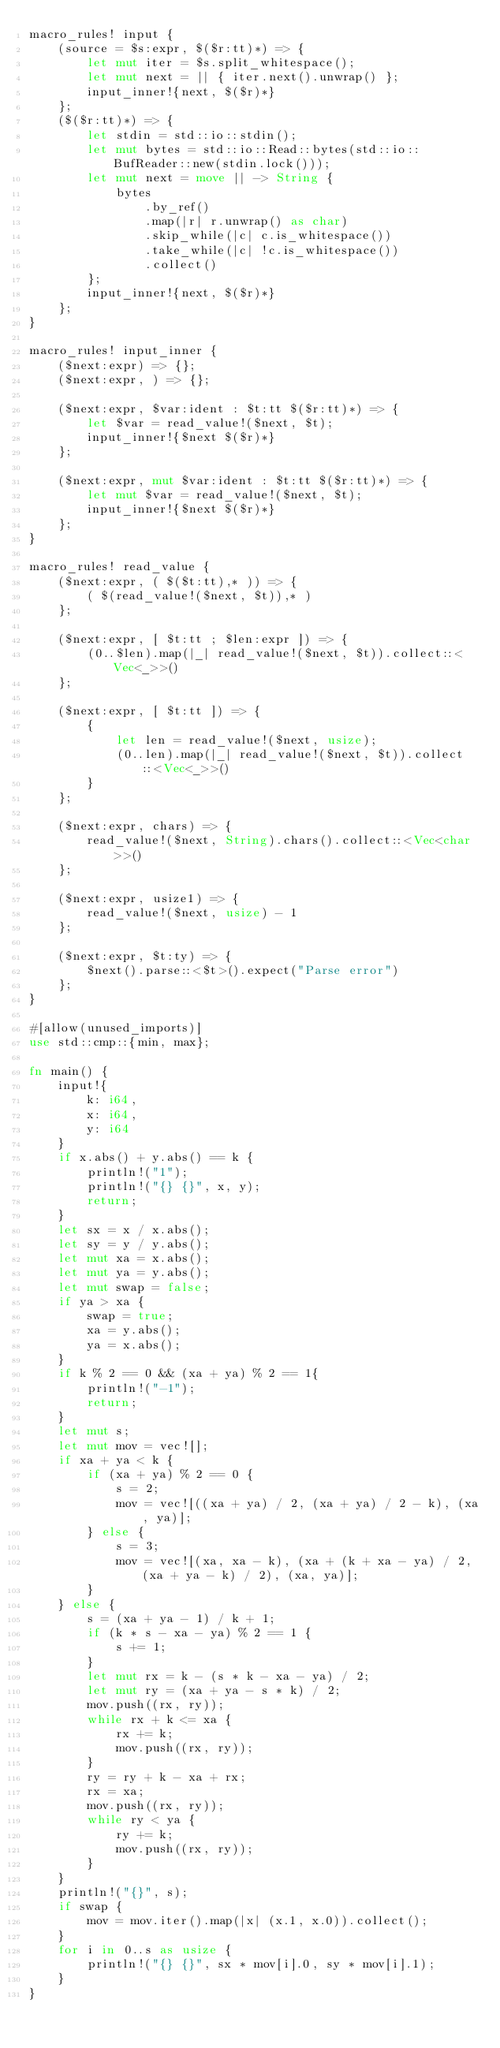Convert code to text. <code><loc_0><loc_0><loc_500><loc_500><_Rust_>macro_rules! input {
    (source = $s:expr, $($r:tt)*) => {
        let mut iter = $s.split_whitespace();
        let mut next = || { iter.next().unwrap() };
        input_inner!{next, $($r)*}
    };
    ($($r:tt)*) => {
        let stdin = std::io::stdin();
        let mut bytes = std::io::Read::bytes(std::io::BufReader::new(stdin.lock()));
        let mut next = move || -> String {
            bytes
                .by_ref()
                .map(|r| r.unwrap() as char)
                .skip_while(|c| c.is_whitespace())
                .take_while(|c| !c.is_whitespace())
                .collect()
        };
        input_inner!{next, $($r)*}
    };
}

macro_rules! input_inner {
    ($next:expr) => {};
    ($next:expr, ) => {};

    ($next:expr, $var:ident : $t:tt $($r:tt)*) => {
        let $var = read_value!($next, $t);
        input_inner!{$next $($r)*}
    };

    ($next:expr, mut $var:ident : $t:tt $($r:tt)*) => {
        let mut $var = read_value!($next, $t);
        input_inner!{$next $($r)*}
    };
}

macro_rules! read_value {
    ($next:expr, ( $($t:tt),* )) => {
        ( $(read_value!($next, $t)),* )
    };

    ($next:expr, [ $t:tt ; $len:expr ]) => {
        (0..$len).map(|_| read_value!($next, $t)).collect::<Vec<_>>()
    };

    ($next:expr, [ $t:tt ]) => {
        {
            let len = read_value!($next, usize);
            (0..len).map(|_| read_value!($next, $t)).collect::<Vec<_>>()
        }
    };

    ($next:expr, chars) => {
        read_value!($next, String).chars().collect::<Vec<char>>()
    };

    ($next:expr, usize1) => {
        read_value!($next, usize) - 1
    };

    ($next:expr, $t:ty) => {
        $next().parse::<$t>().expect("Parse error")
    };
}

#[allow(unused_imports)]
use std::cmp::{min, max};

fn main() {
    input!{
        k: i64,
        x: i64,
        y: i64
    }
    if x.abs() + y.abs() == k {
        println!("1");
        println!("{} {}", x, y);
        return;
    }
    let sx = x / x.abs();
    let sy = y / y.abs();
    let mut xa = x.abs();
    let mut ya = y.abs();
    let mut swap = false;
    if ya > xa {
        swap = true;
        xa = y.abs();
        ya = x.abs();
    }
    if k % 2 == 0 && (xa + ya) % 2 == 1{
        println!("-1");
        return;
    }
    let mut s;
    let mut mov = vec![];
    if xa + ya < k {
        if (xa + ya) % 2 == 0 {
            s = 2;
            mov = vec![((xa + ya) / 2, (xa + ya) / 2 - k), (xa, ya)];
        } else {
            s = 3;
            mov = vec![(xa, xa - k), (xa + (k + xa - ya) / 2, (xa + ya - k) / 2), (xa, ya)];
        }
    } else {
        s = (xa + ya - 1) / k + 1;
        if (k * s - xa - ya) % 2 == 1 {
            s += 1;
        }
        let mut rx = k - (s * k - xa - ya) / 2;
        let mut ry = (xa + ya - s * k) / 2;
        mov.push((rx, ry));
        while rx + k <= xa {
            rx += k;
            mov.push((rx, ry));
        }
        ry = ry + k - xa + rx;
        rx = xa;
        mov.push((rx, ry));
        while ry < ya {
            ry += k;
            mov.push((rx, ry));
        }
    }
    println!("{}", s);
    if swap {
        mov = mov.iter().map(|x| (x.1, x.0)).collect();
    }
    for i in 0..s as usize {
        println!("{} {}", sx * mov[i].0, sy * mov[i].1);
    }
}
</code> 